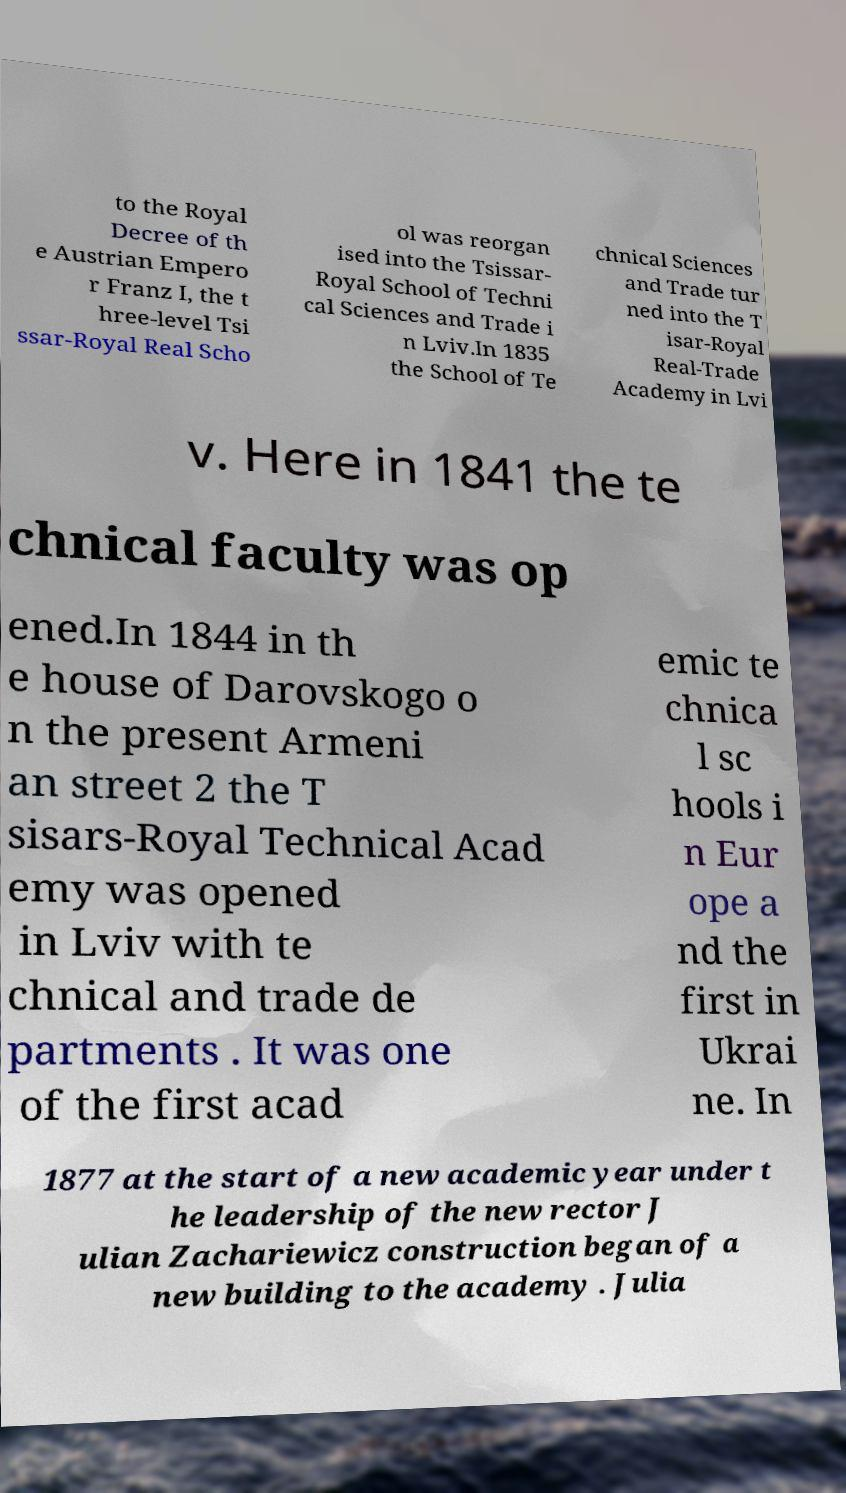Please identify and transcribe the text found in this image. to the Royal Decree of th e Austrian Empero r Franz I, the t hree-level Tsi ssar-Royal Real Scho ol was reorgan ised into the Tsissar- Royal School of Techni cal Sciences and Trade i n Lviv.In 1835 the School of Te chnical Sciences and Trade tur ned into the T isar-Royal Real-Trade Academy in Lvi v. Here in 1841 the te chnical faculty was op ened.In 1844 in th e house of Darovskogo o n the present Armeni an street 2 the T sisars-Royal Technical Acad emy was opened in Lviv with te chnical and trade de partments . It was one of the first acad emic te chnica l sc hools i n Eur ope a nd the first in Ukrai ne. In 1877 at the start of a new academic year under t he leadership of the new rector J ulian Zachariewicz construction began of a new building to the academy . Julia 